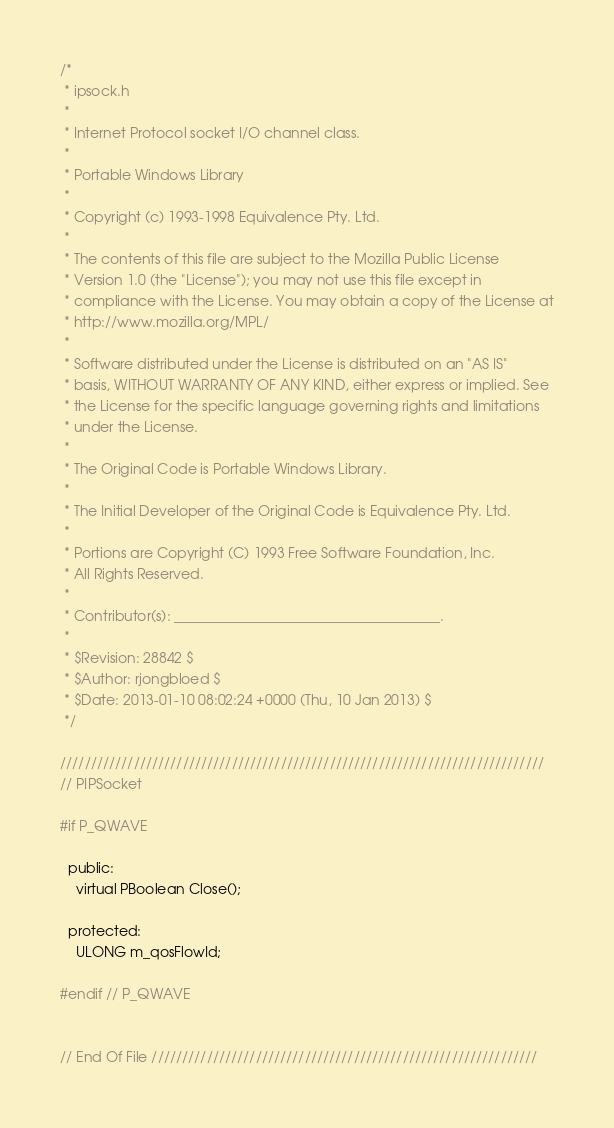<code> <loc_0><loc_0><loc_500><loc_500><_C_>/*
 * ipsock.h
 *
 * Internet Protocol socket I/O channel class.
 *
 * Portable Windows Library
 *
 * Copyright (c) 1993-1998 Equivalence Pty. Ltd.
 *
 * The contents of this file are subject to the Mozilla Public License
 * Version 1.0 (the "License"); you may not use this file except in
 * compliance with the License. You may obtain a copy of the License at
 * http://www.mozilla.org/MPL/
 *
 * Software distributed under the License is distributed on an "AS IS"
 * basis, WITHOUT WARRANTY OF ANY KIND, either express or implied. See
 * the License for the specific language governing rights and limitations
 * under the License.
 *
 * The Original Code is Portable Windows Library.
 *
 * The Initial Developer of the Original Code is Equivalence Pty. Ltd.
 *
 * Portions are Copyright (C) 1993 Free Software Foundation, Inc.
 * All Rights Reserved.
 *
 * Contributor(s): ______________________________________.
 *
 * $Revision: 28842 $
 * $Author: rjongbloed $
 * $Date: 2013-01-10 08:02:24 +0000 (Thu, 10 Jan 2013) $
 */

///////////////////////////////////////////////////////////////////////////////
// PIPSocket

#if P_QWAVE

  public:
    virtual PBoolean Close();

  protected:
    ULONG m_qosFlowId;

#endif // P_QWAVE


// End Of File ///////////////////////////////////////////////////////////////
</code> 